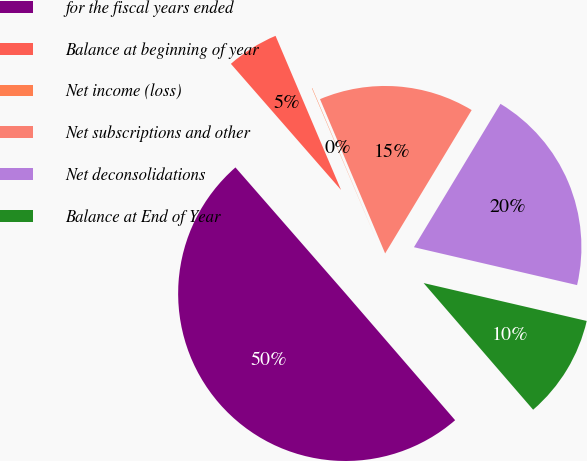Convert chart. <chart><loc_0><loc_0><loc_500><loc_500><pie_chart><fcel>for the fiscal years ended<fcel>Balance at beginning of year<fcel>Net income (loss)<fcel>Net subscriptions and other<fcel>Net deconsolidations<fcel>Balance at End of Year<nl><fcel>49.92%<fcel>5.03%<fcel>0.04%<fcel>15.0%<fcel>19.99%<fcel>10.02%<nl></chart> 